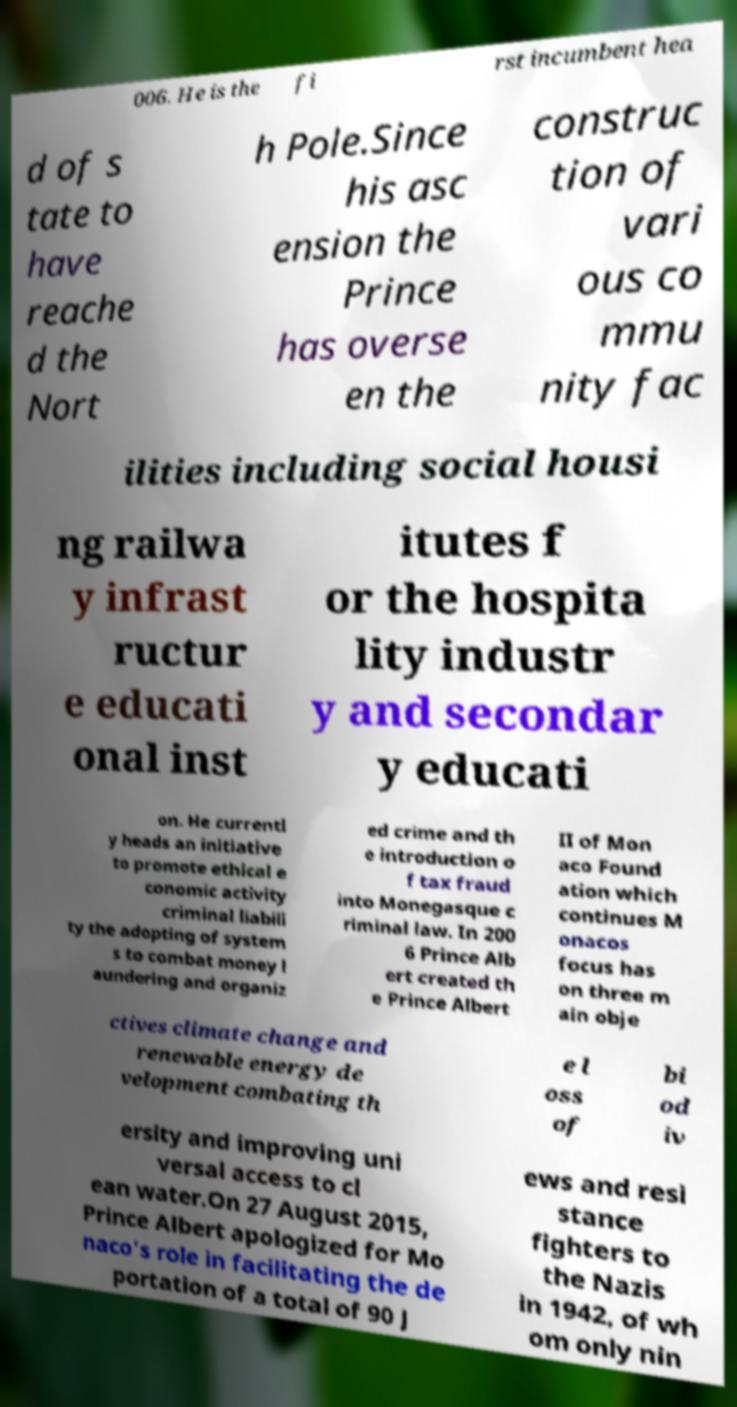Could you extract and type out the text from this image? 006. He is the fi rst incumbent hea d of s tate to have reache d the Nort h Pole.Since his asc ension the Prince has overse en the construc tion of vari ous co mmu nity fac ilities including social housi ng railwa y infrast ructur e educati onal inst itutes f or the hospita lity industr y and secondar y educati on. He currentl y heads an initiative to promote ethical e conomic activity criminal liabili ty the adopting of system s to combat money l aundering and organiz ed crime and th e introduction o f tax fraud into Monegasque c riminal law. In 200 6 Prince Alb ert created th e Prince Albert II of Mon aco Found ation which continues M onacos focus has on three m ain obje ctives climate change and renewable energy de velopment combating th e l oss of bi od iv ersity and improving uni versal access to cl ean water.On 27 August 2015, Prince Albert apologized for Mo naco's role in facilitating the de portation of a total of 90 J ews and resi stance fighters to the Nazis in 1942, of wh om only nin 